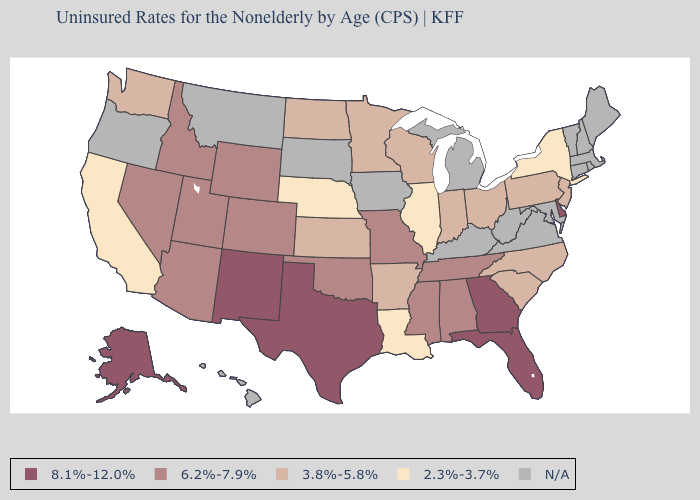How many symbols are there in the legend?
Keep it brief. 5. What is the lowest value in states that border Montana?
Short answer required. 3.8%-5.8%. What is the value of South Carolina?
Concise answer only. 3.8%-5.8%. Which states have the lowest value in the USA?
Concise answer only. California, Illinois, Louisiana, Nebraska, New York. Does Florida have the lowest value in the USA?
Concise answer only. No. Does Illinois have the lowest value in the USA?
Write a very short answer. Yes. Which states have the highest value in the USA?
Write a very short answer. Alaska, Delaware, Florida, Georgia, New Mexico, Texas. Name the states that have a value in the range N/A?
Answer briefly. Connecticut, Hawaii, Iowa, Kentucky, Maine, Maryland, Massachusetts, Michigan, Montana, New Hampshire, Oregon, Rhode Island, South Dakota, Vermont, Virginia, West Virginia. Among the states that border Maryland , does Delaware have the lowest value?
Keep it brief. No. Which states have the lowest value in the USA?
Write a very short answer. California, Illinois, Louisiana, Nebraska, New York. Which states have the lowest value in the USA?
Keep it brief. California, Illinois, Louisiana, Nebraska, New York. Name the states that have a value in the range 6.2%-7.9%?
Keep it brief. Alabama, Arizona, Colorado, Idaho, Mississippi, Missouri, Nevada, Oklahoma, Tennessee, Utah, Wyoming. Name the states that have a value in the range 2.3%-3.7%?
Quick response, please. California, Illinois, Louisiana, Nebraska, New York. What is the highest value in the USA?
Answer briefly. 8.1%-12.0%. Which states have the lowest value in the USA?
Give a very brief answer. California, Illinois, Louisiana, Nebraska, New York. 